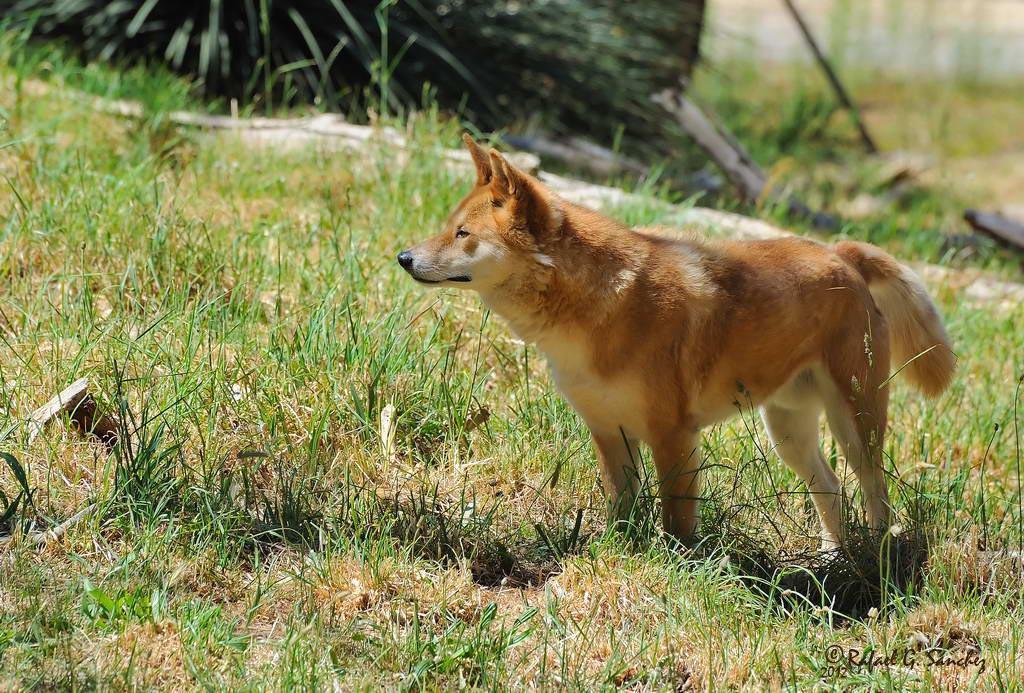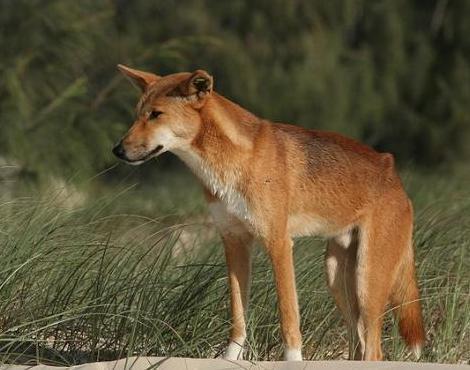The first image is the image on the left, the second image is the image on the right. Assess this claim about the two images: "There are two dogs". Correct or not? Answer yes or no. Yes. The first image is the image on the left, the second image is the image on the right. Evaluate the accuracy of this statement regarding the images: "Left image shows two dogs and right image shows one dog.". Is it true? Answer yes or no. No. 